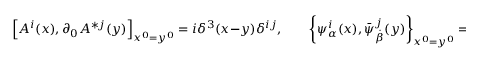Convert formula to latex. <formula><loc_0><loc_0><loc_500><loc_500>\left [ A ^ { i } ( x ) , \partial _ { 0 } A ^ { * j } ( y ) \right ] _ { x ^ { 0 } = y ^ { 0 } } = i \delta ^ { 3 } ( x - y ) \delta ^ { i j } , \quad \left \{ \psi _ { \alpha } ^ { i } ( x ) , \bar { \psi } _ { \dot { \beta } } ^ { j } ( y ) \right \} _ { x ^ { 0 } = y ^ { 0 } } = - \delta ^ { 3 } ( x - y ) \delta ^ { i j } \sigma _ { \alpha \dot { \beta } } ^ { 0 } .</formula> 